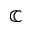Convert formula to latex. <formula><loc_0><loc_0><loc_500><loc_500>\mathbb { C }</formula> 